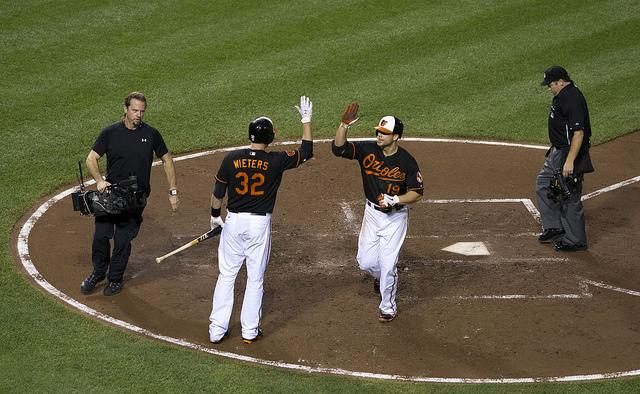What category of animal is their mascot in? Please explain your reasoning. bird. Their team is the orioles. 